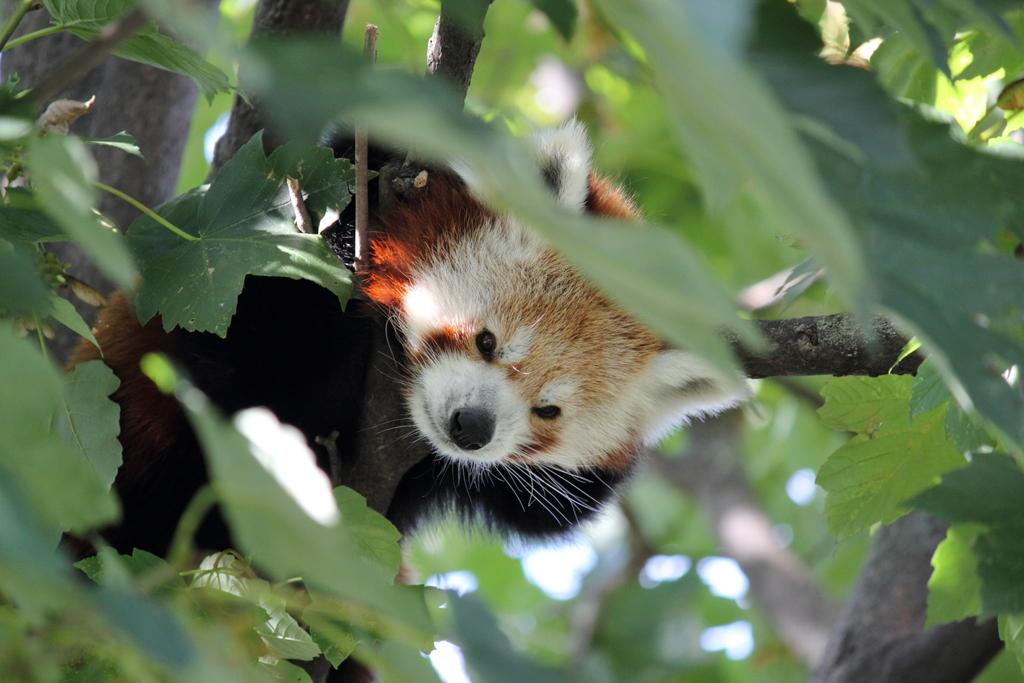What type of natural elements can be seen in the image? There are leaves and branches of a tree in the image. Can you describe the animal visible behind the leaves in the image? Unfortunately, the image does not provide enough detail to identify the specific animal behind the leaves. What type of pleasure can be seen being experienced by the cat in the image? There is no cat present in the image, so it is not possible to determine what type of pleasure might be experienced. 